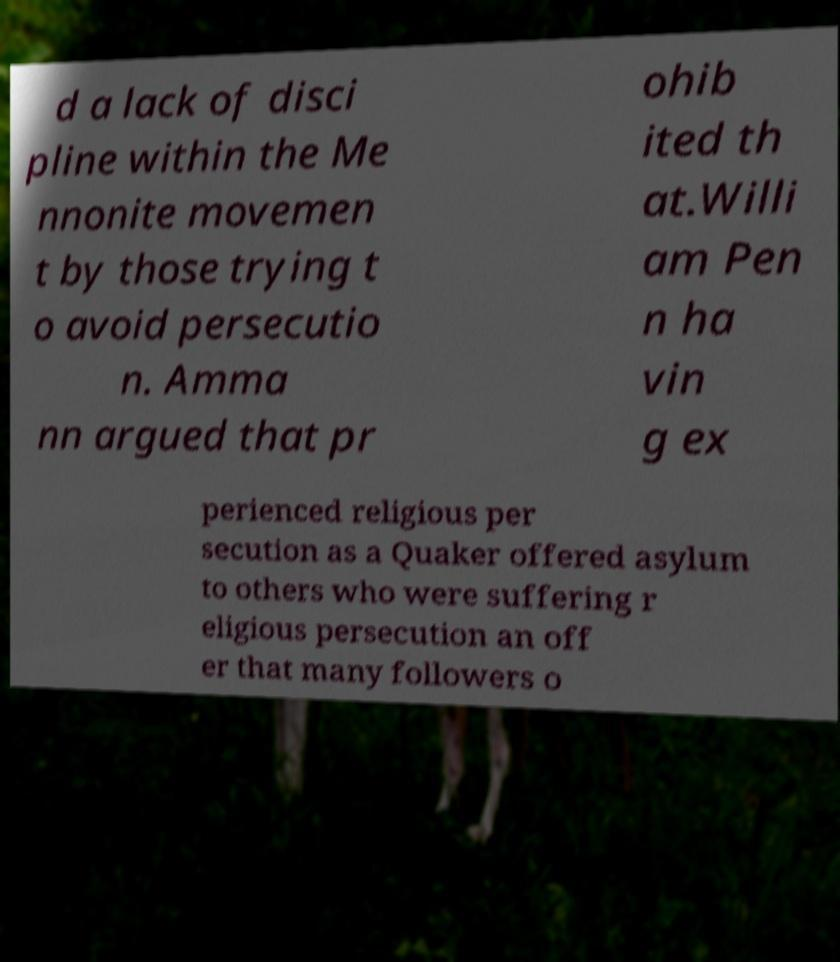Can you read and provide the text displayed in the image?This photo seems to have some interesting text. Can you extract and type it out for me? d a lack of disci pline within the Me nnonite movemen t by those trying t o avoid persecutio n. Amma nn argued that pr ohib ited th at.Willi am Pen n ha vin g ex perienced religious per secution as a Quaker offered asylum to others who were suffering r eligious persecution an off er that many followers o 